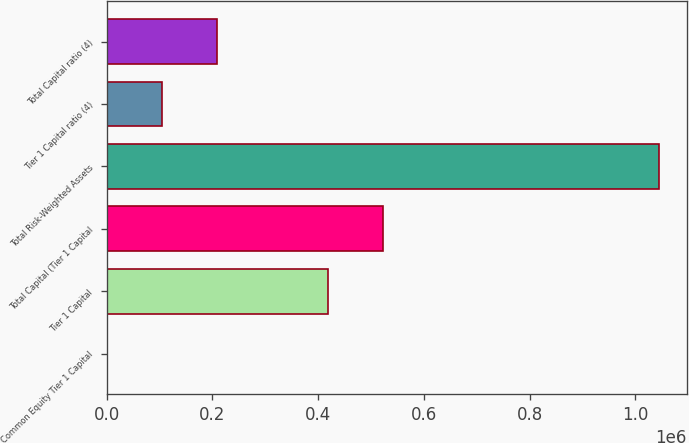Convert chart to OTSL. <chart><loc_0><loc_0><loc_500><loc_500><bar_chart><fcel>Common Equity Tier 1 Capital<fcel>Tier 1 Capital<fcel>Total Capital (Tier 1 Capital<fcel>Total Risk-Weighted Assets<fcel>Tier 1 Capital ratio (4)<fcel>Total Capital ratio (4)<nl><fcel>12.28<fcel>417915<fcel>522390<fcel>1.04477e+06<fcel>104488<fcel>208963<nl></chart> 